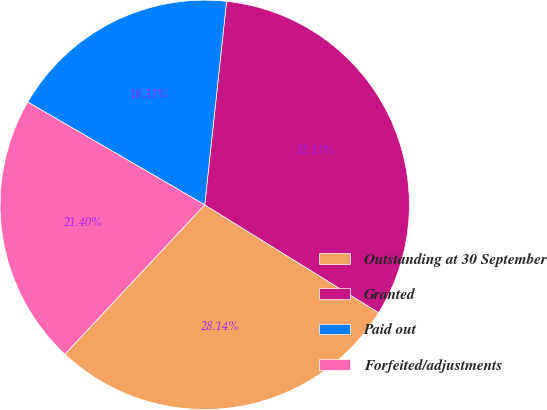<chart> <loc_0><loc_0><loc_500><loc_500><pie_chart><fcel>Outstanding at 30 September<fcel>Granted<fcel>Paid out<fcel>Forfeited/adjustments<nl><fcel>28.14%<fcel>32.13%<fcel>18.33%<fcel>21.4%<nl></chart> 